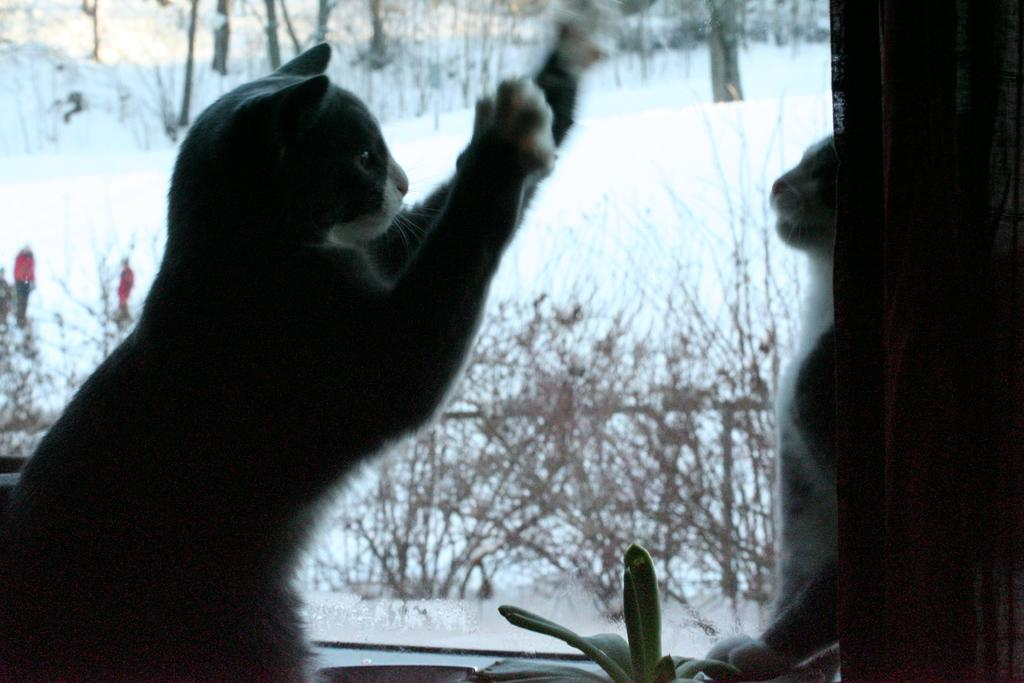What animals are in the middle of the image? There are two cats in the middle of the image. What is located behind the cats? There are plants behind the cats. What is the ground made of in the image? Snow is visible behind the plants. What can be seen at the top of the image? Trees are present at the top of the image. Where is the scarecrow located in the image? There is no scarecrow present in the image. What type of adjustment can be seen being made to the trees in the image? There is no adjustment being made to the trees in the image; they are simply present in the background. 